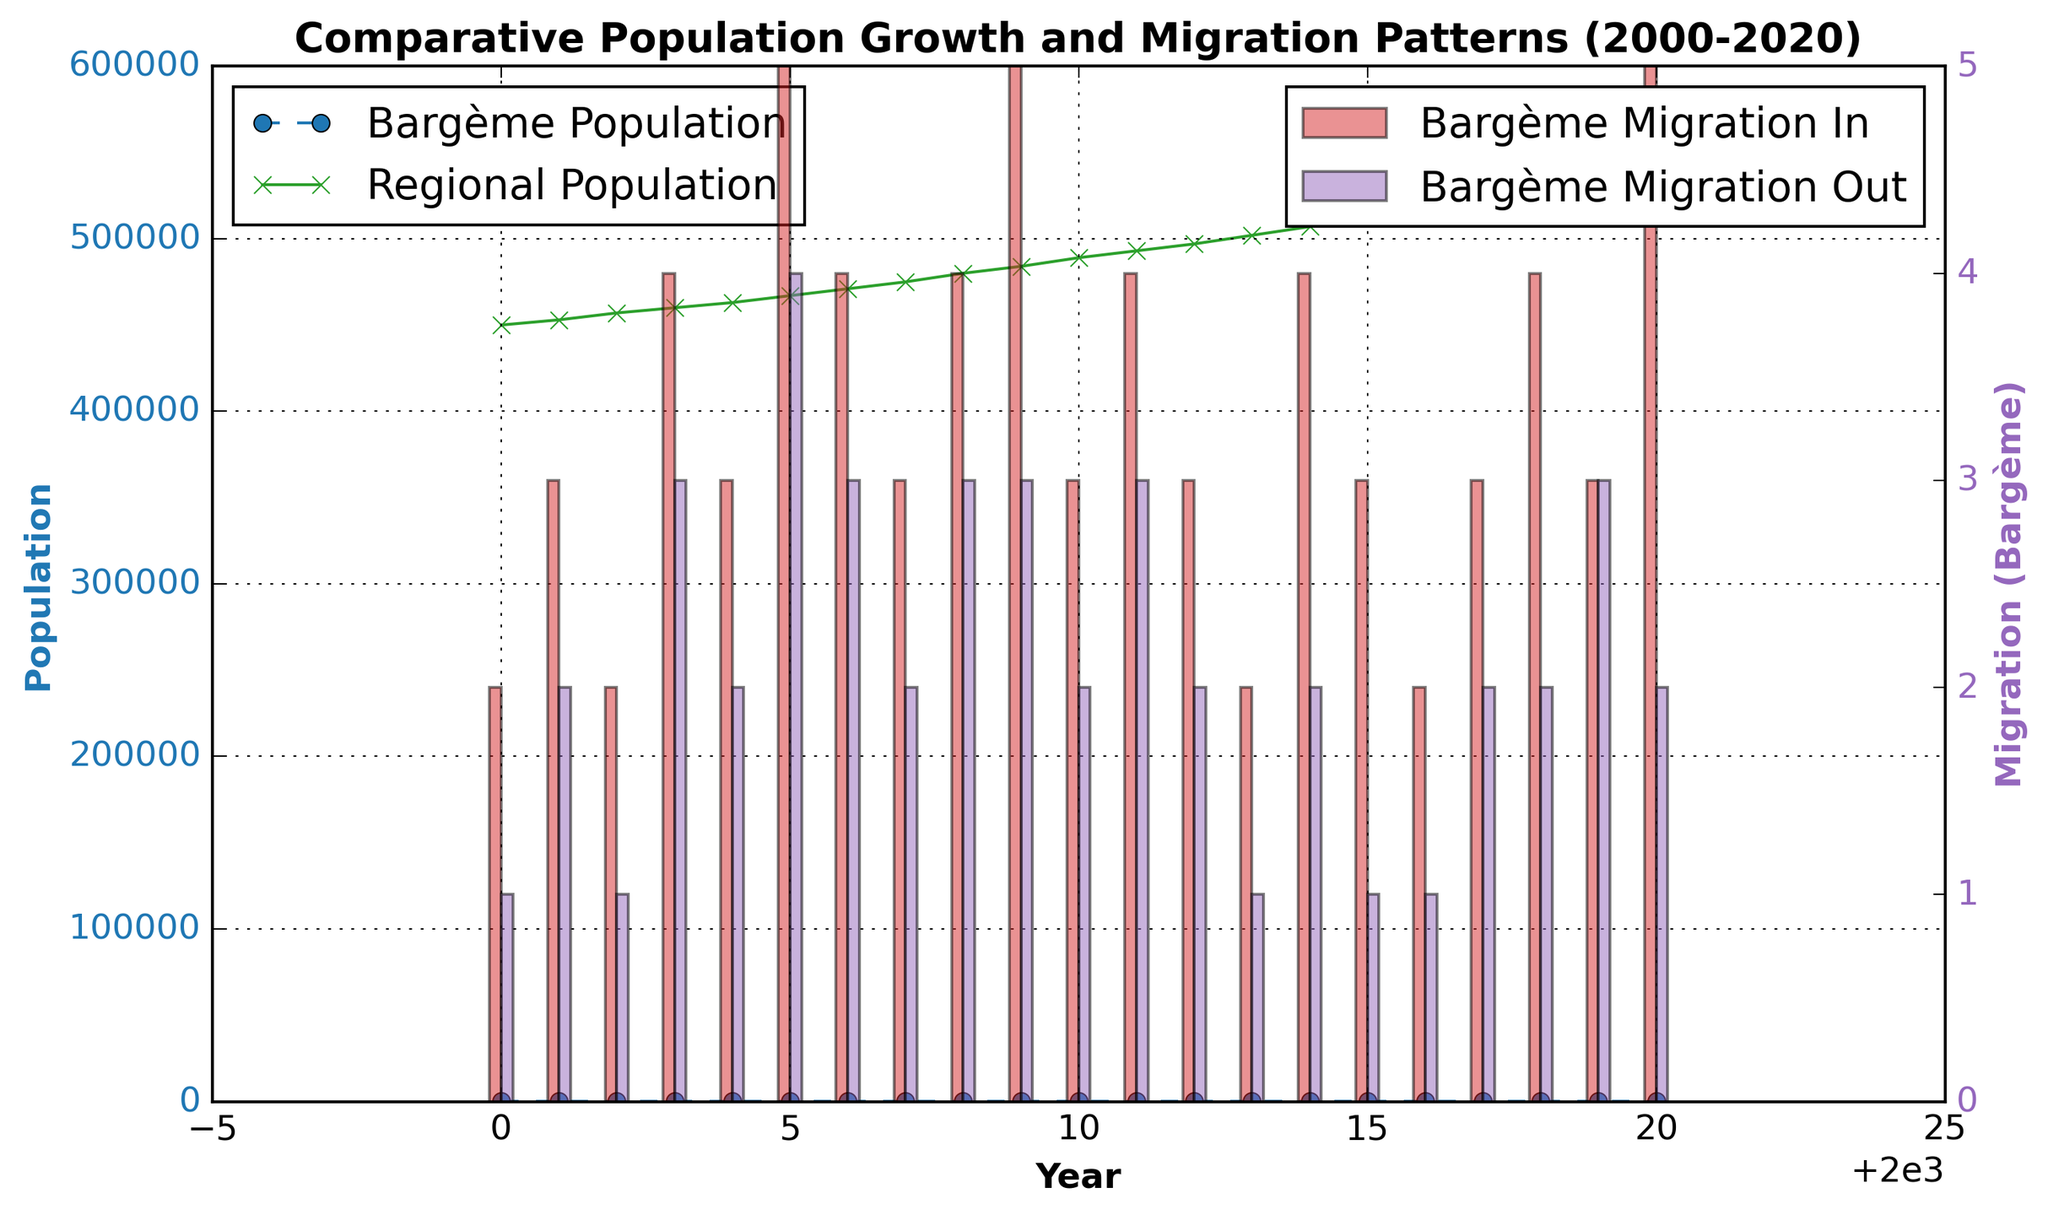Which year saw the highest population in Bargème? By examining the plot line representing Bargème Population, we see that the highest value is at the end of the timeline, in the year 2020.
Answer: 2020 How does the population growth trend of Bargème compare to the regional population growth? By visually inspecting both the population lines, Bargème shows a steady, linear increase over time, while the regional population also consistently increases but appears to grow at a larger scale.
Answer: Both increase steadily, but regional population grows larger In which year did Bargème experience the highest migration inflow? Refer to the height of the red bars representing 'Bargème Migration In.' The highest bar is observed in 2020, indicating the greatest inflow.
Answer: 2020 Compare the migration outflows of Bargème in 2003 and 2020. The heights of the purple bars for 'Bargème Migration Out' in 2003 and 2020 need to be compared visually. In 2003, the value is 3, whereas in 2020, it is 2.
Answer: Higher in 2003 Calculate the average population of Bargème over the period from 2000 to 2020. Sum the populations from 2000 to 2020 (80+81+82+...+100) and divide by the number of years (21). Comparison should be based on data points along the Y-axis for each year within this period.
Answer: 90 Which year had the closest migration inflow and outflow for Bargème? For each year, compare the red and purple bars visually. The year 2019 has equal heights for inflow and outflow bars, depicting three people for each.
Answer: 2019 What is the population difference between Bargème and the regional average in 2010? Subtract Bargème's population (90) from the Regional population (489000) in 2010. The exact difference between these two data lines can be checked at the corresponding point in the figure.
Answer: 488910 Did Bargème's migration inflow ever fall below 3 between 2000 and 2020? Inspect the height of the red bars over the given period. Several years (2000, 2002, 2013, 2016) show height lower than 3.
Answer: Yes How many times did the population of Bargème increase by more than one person in successive years? Compare the population values from year to year to identify increments greater than one (2004-2005, 2008-2009). This can be manually counted or calculated.
Answer: Twice What is the visual difference between the migration inflow bar in 2005 and 2008 for Bargème? Visually compare the height of the red bars for the years 2005 and 2008. Both are similarly high, but 2005 shows a slightly shorter red bar indicating an inflow of 5, whereas 2008 shows also 4.
Answer: No significant visual difference 